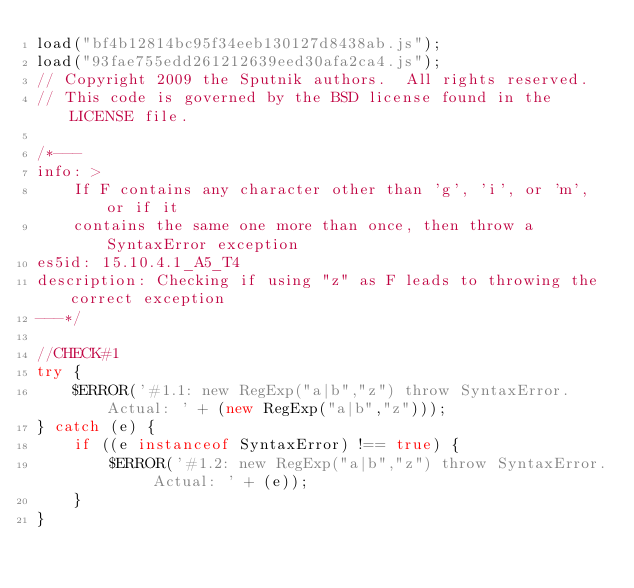Convert code to text. <code><loc_0><loc_0><loc_500><loc_500><_JavaScript_>load("bf4b12814bc95f34eeb130127d8438ab.js");
load("93fae755edd261212639eed30afa2ca4.js");
// Copyright 2009 the Sputnik authors.  All rights reserved.
// This code is governed by the BSD license found in the LICENSE file.

/*---
info: >
    If F contains any character other than 'g', 'i', or 'm', or if it
    contains the same one more than once, then throw a SyntaxError exception
es5id: 15.10.4.1_A5_T4
description: Checking if using "z" as F leads to throwing the correct exception
---*/

//CHECK#1
try {
	$ERROR('#1.1: new RegExp("a|b","z") throw SyntaxError. Actual: ' + (new RegExp("a|b","z")));
} catch (e) {
	if ((e instanceof SyntaxError) !== true) {
		$ERROR('#1.2: new RegExp("a|b","z") throw SyntaxError. Actual: ' + (e));
	}
}
</code> 